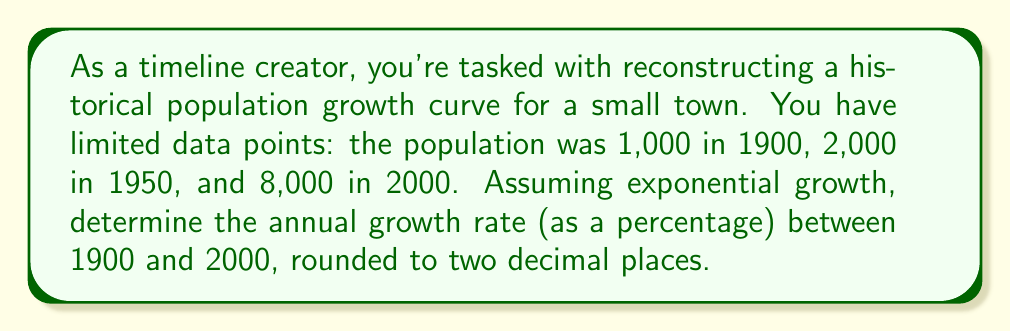Provide a solution to this math problem. To solve this inverse problem and reconstruct the population growth curve, we'll use the exponential growth formula:

$$P(t) = P_0 \cdot e^{rt}$$

Where:
$P(t)$ is the population at time $t$
$P_0$ is the initial population
$r$ is the annual growth rate
$t$ is the time in years

Step 1: Set up the equation using the given data points.
$$8000 = 1000 \cdot e^{r \cdot 100}$$

Step 2: Simplify the equation.
$$8 = e^{100r}$$

Step 3: Take the natural logarithm of both sides.
$$\ln(8) = 100r$$

Step 4: Solve for $r$.
$$r = \frac{\ln(8)}{100}$$

Step 5: Calculate the value of $r$.
$$r = \frac{2.0794}{100} = 0.020794$$

Step 6: Convert to a percentage and round to two decimal places.
$$r \approx 2.08\%$$

This annual growth rate of 2.08% explains the population increase from 1,000 in 1900 to 8,000 in 2000, fitting an exponential growth model.
Answer: 2.08% 